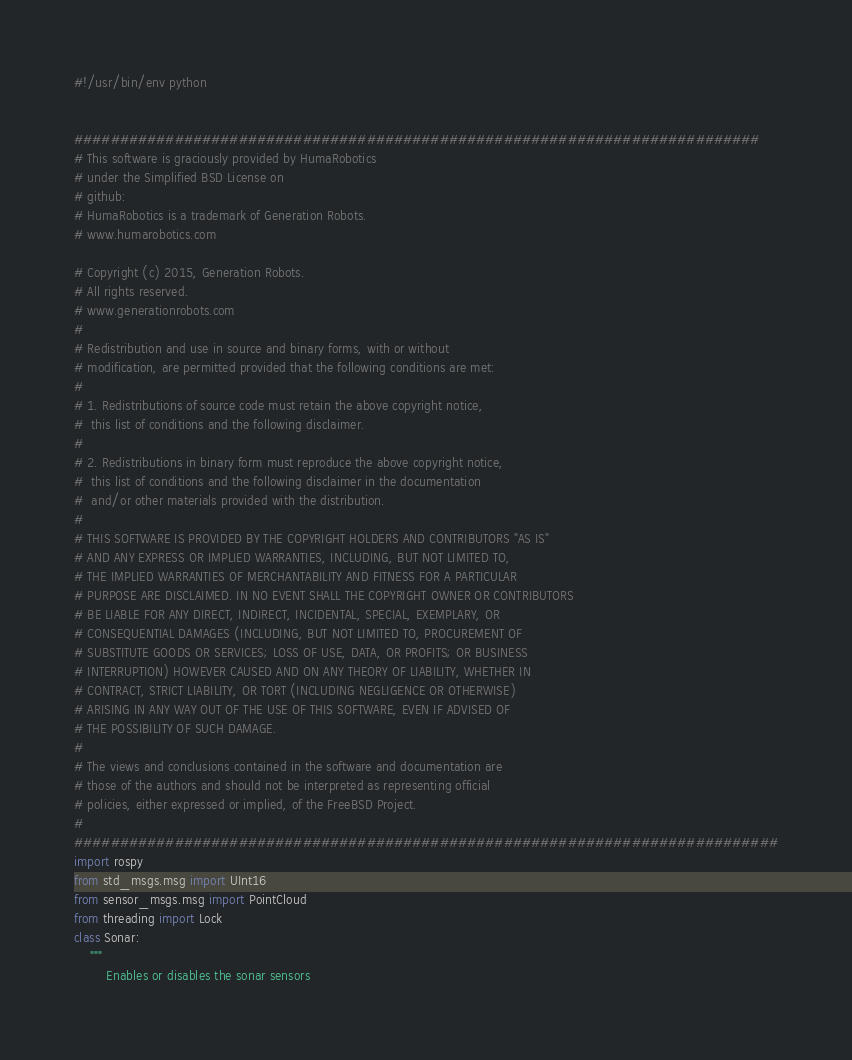<code> <loc_0><loc_0><loc_500><loc_500><_Python_>#!/usr/bin/env python


########################################################################### 
# This software is graciously provided by HumaRobotics 
# under the Simplified BSD License on
# github: 
# HumaRobotics is a trademark of Generation Robots.
# www.humarobotics.com 

# Copyright (c) 2015, Generation Robots.
# All rights reserved.
# www.generationrobots.com
#   
# Redistribution and use in source and binary forms, with or without 
# modification, are permitted provided that the following conditions are met:
# 
# 1. Redistributions of source code must retain the above copyright notice,
#  this list of conditions and the following disclaimer.
# 
# 2. Redistributions in binary form must reproduce the above copyright notice,
#  this list of conditions and the following disclaimer in the documentation 
#  and/or other materials provided with the distribution.
# 
# THIS SOFTWARE IS PROVIDED BY THE COPYRIGHT HOLDERS AND CONTRIBUTORS "AS IS"
# AND ANY EXPRESS OR IMPLIED WARRANTIES, INCLUDING, BUT NOT LIMITED TO, 
# THE IMPLIED WARRANTIES OF MERCHANTABILITY AND FITNESS FOR A PARTICULAR 
# PURPOSE ARE DISCLAIMED. IN NO EVENT SHALL THE COPYRIGHT OWNER OR CONTRIBUTORS 
# BE LIABLE FOR ANY DIRECT, INDIRECT, INCIDENTAL, SPECIAL, EXEMPLARY, OR 
# CONSEQUENTIAL DAMAGES (INCLUDING, BUT NOT LIMITED TO, PROCUREMENT OF 
# SUBSTITUTE GOODS OR SERVICES; LOSS OF USE, DATA, OR PROFITS; OR BUSINESS 
# INTERRUPTION) HOWEVER CAUSED AND ON ANY THEORY OF LIABILITY, WHETHER IN 
# CONTRACT, STRICT LIABILITY, OR TORT (INCLUDING NEGLIGENCE OR OTHERWISE) 
# ARISING IN ANY WAY OUT OF THE USE OF THIS SOFTWARE, EVEN IF ADVISED OF 
# THE POSSIBILITY OF SUCH DAMAGE. 
# 
# The views and conclusions contained in the software and documentation are 
# those of the authors and should not be interpreted as representing official 
# policies, either expressed or implied, of the FreeBSD Project.
#
#############################################################################
import rospy
from std_msgs.msg import UInt16
from sensor_msgs.msg import PointCloud
from threading import Lock
class Sonar:
    """
        Enables or disables the sonar sensors</code> 